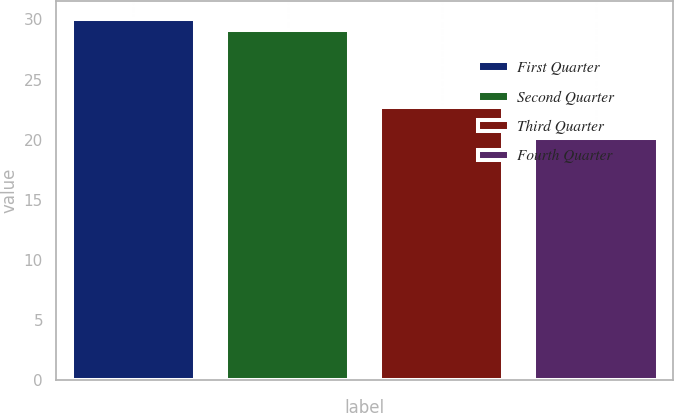Convert chart. <chart><loc_0><loc_0><loc_500><loc_500><bar_chart><fcel>First Quarter<fcel>Second Quarter<fcel>Third Quarter<fcel>Fourth Quarter<nl><fcel>30.01<fcel>29.1<fcel>22.72<fcel>20.14<nl></chart> 